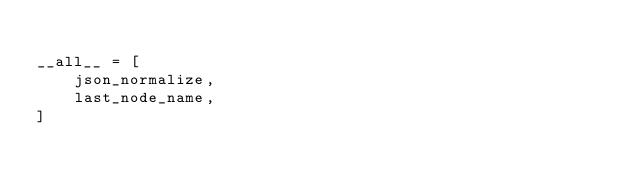<code> <loc_0><loc_0><loc_500><loc_500><_Python_>
__all__ = [
    json_normalize,
    last_node_name,
]
</code> 